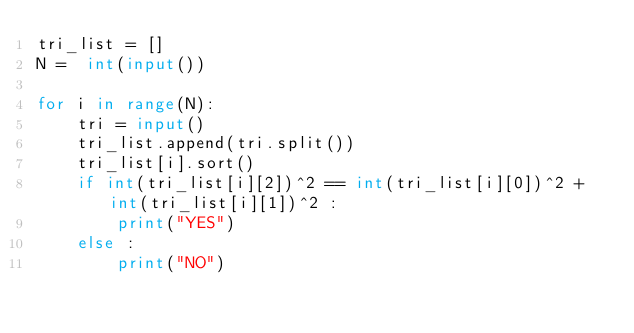<code> <loc_0><loc_0><loc_500><loc_500><_Python_>tri_list = []
N =  int(input())

for i in range(N):
    tri = input()
    tri_list.append(tri.split())
    tri_list[i].sort()
    if int(tri_list[i][2])^2 == int(tri_list[i][0])^2 + int(tri_list[i][1])^2 :
        print("YES")
    else :
        print("NO")
</code> 